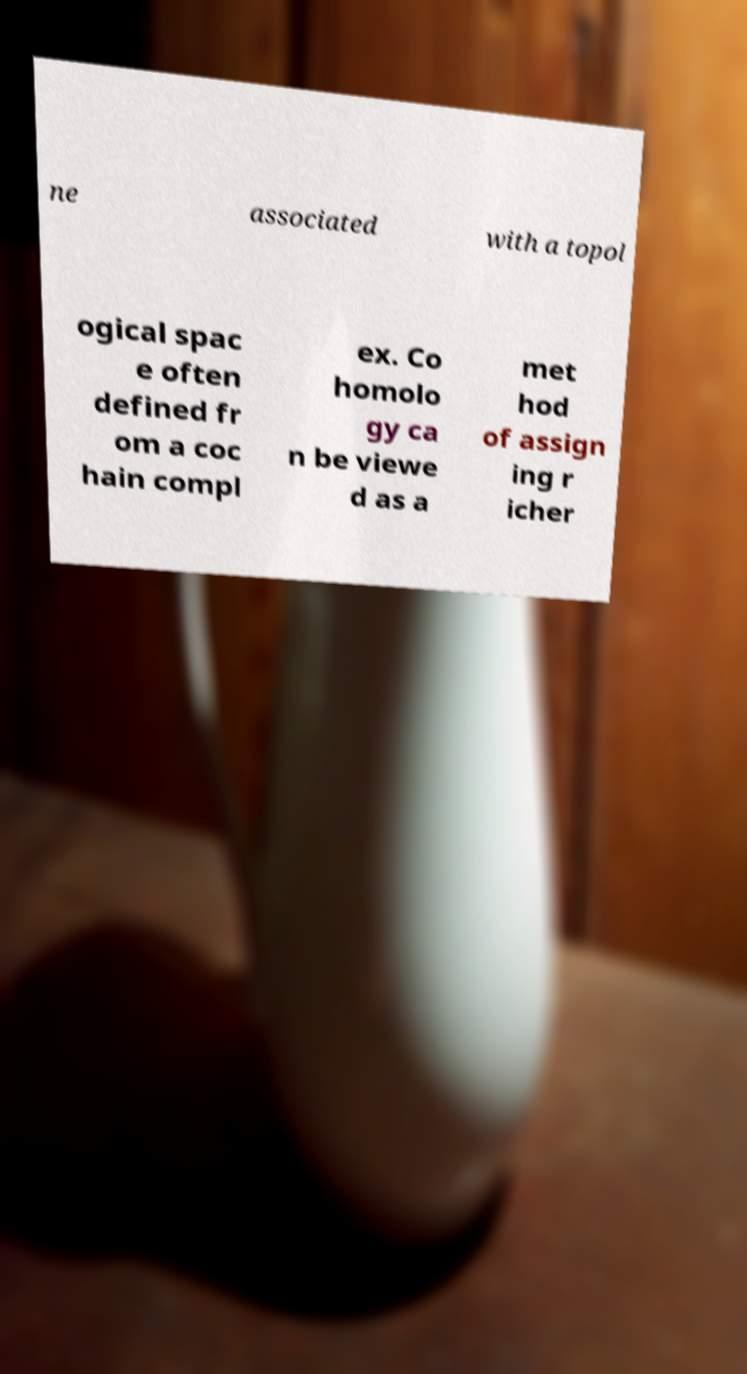Please read and relay the text visible in this image. What does it say? ne associated with a topol ogical spac e often defined fr om a coc hain compl ex. Co homolo gy ca n be viewe d as a met hod of assign ing r icher 